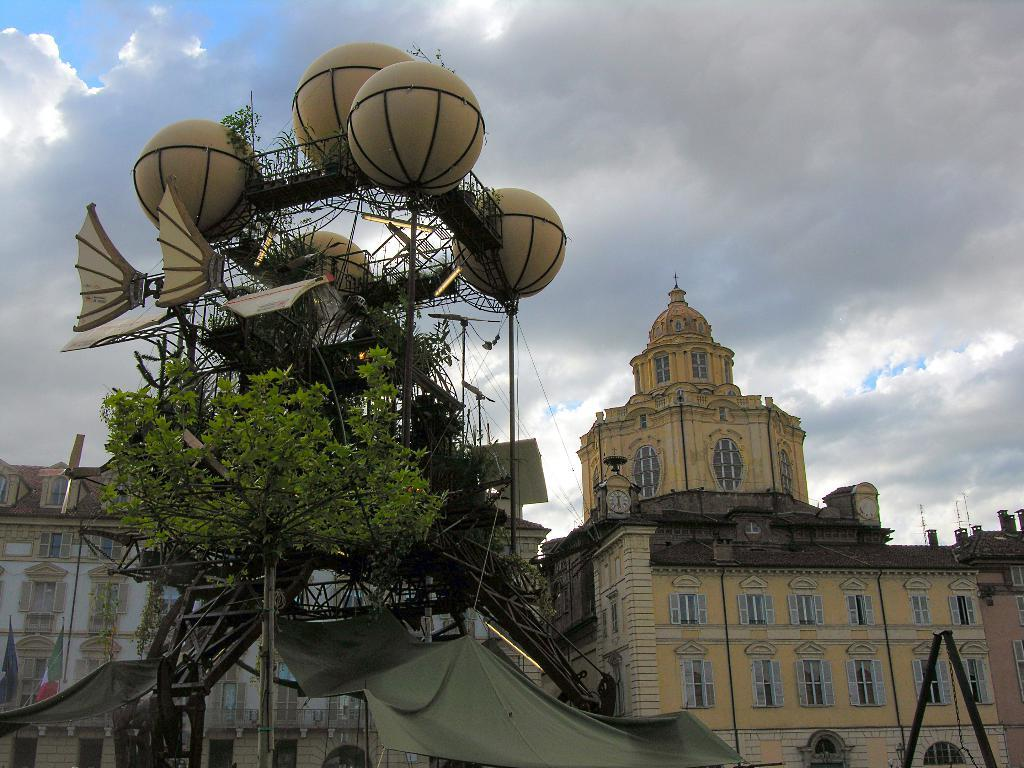What type of structures can be seen in the image? There are huge buildings in the image. What else is present in the image besides the buildings? There is a giant object in the image. Can you describe the placement of the tree in the image? There is a tree in front of the giant object. What type of flowers can be seen growing in the alley in the image? There is no alley or flowers present in the image. 